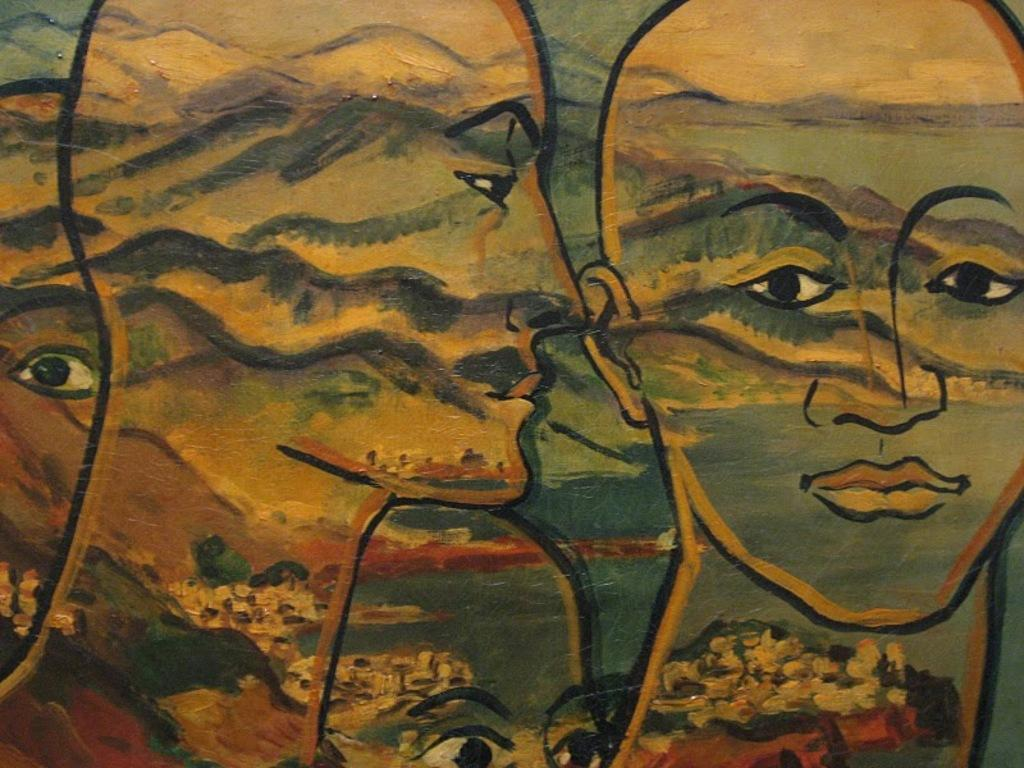What is the main subject in the center of the image? There is a painting in the center of the image. What does the painting depict? The painting depicts persons. How many balls are visible in the painting? There are no balls visible in the painting; it depicts persons. Is there a window in the painting? There is no window depicted in the painting; it only shows persons. 